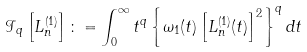Convert formula to latex. <formula><loc_0><loc_0><loc_500><loc_500>\mathcal { I } _ { q } \left [ L _ { n } ^ { ( 1 ) } \right ] \colon = \int _ { 0 } ^ { \infty } t ^ { q } \left \{ \omega _ { 1 } ( t ) \left [ L _ { n } ^ { ( 1 ) } ( t ) \right ] ^ { 2 } \right \} ^ { q } d t</formula> 